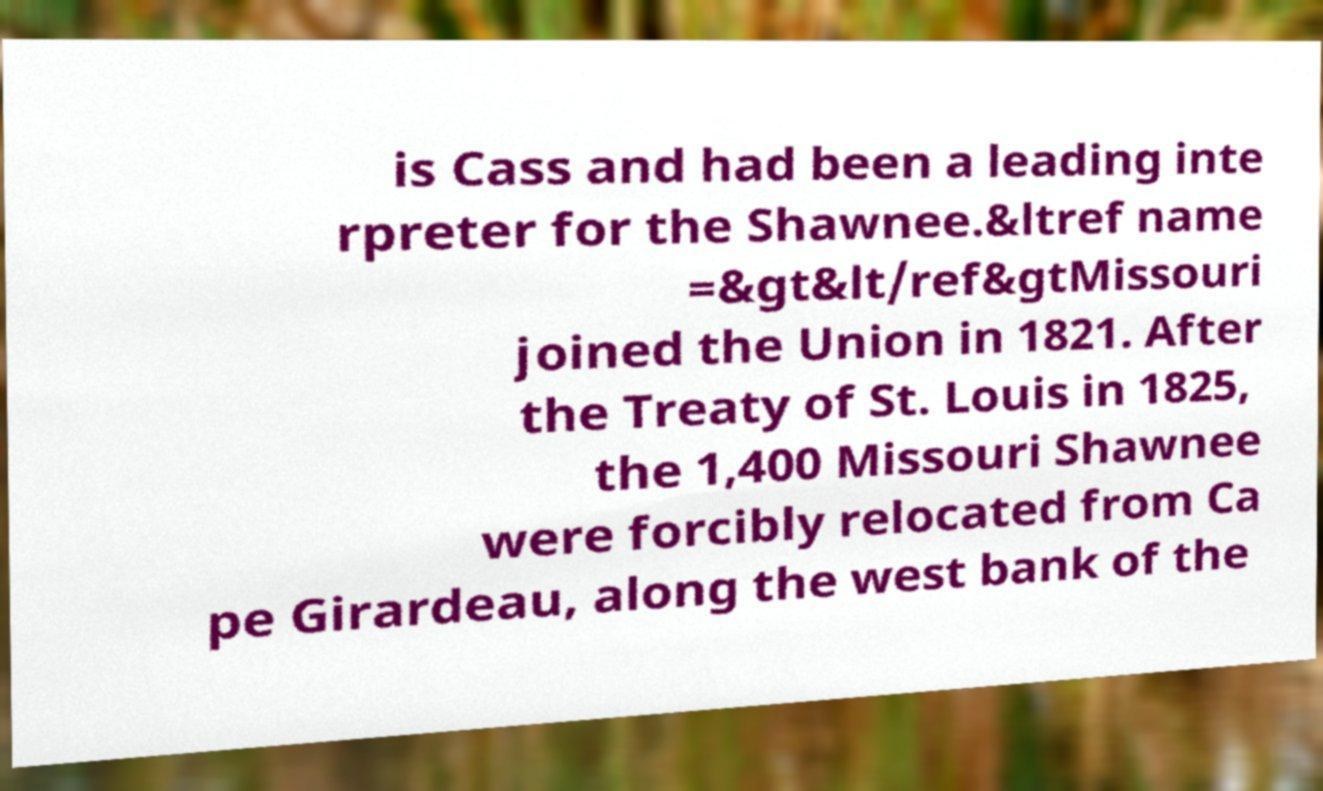Can you accurately transcribe the text from the provided image for me? is Cass and had been a leading inte rpreter for the Shawnee.&ltref name =&gt&lt/ref&gtMissouri joined the Union in 1821. After the Treaty of St. Louis in 1825, the 1,400 Missouri Shawnee were forcibly relocated from Ca pe Girardeau, along the west bank of the 